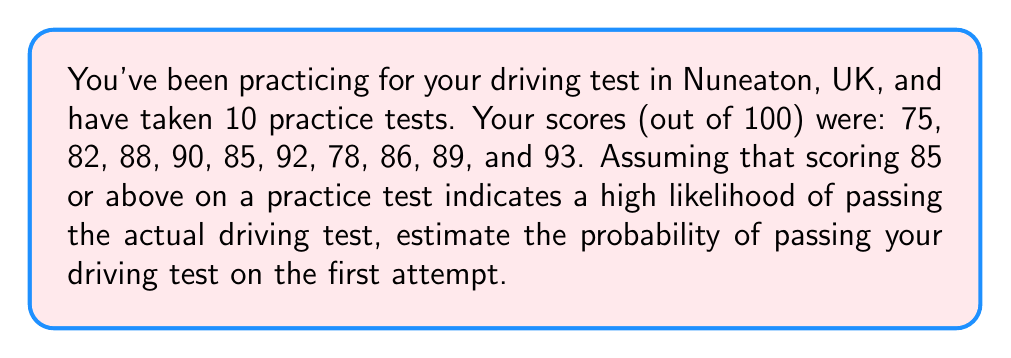Can you solve this math problem? To estimate the probability of passing the driving test on the first attempt, we'll use the given information that scoring 85 or above on a practice test indicates a high likelihood of passing. We'll treat each practice test as an independent event and calculate the proportion of tests where you scored 85 or above.

1. Count the number of practice tests with scores of 85 or above:
   85, 90, 85, 92, 86, 89, 93
   There are 7 scores that meet this criterion.

2. Calculate the probability using the formula:

   $$P(\text{passing}) = \frac{\text{Number of favorable outcomes}}{\text{Total number of outcomes}}$$

   $$P(\text{passing}) = \frac{7}{10} = 0.7$$

3. Convert the decimal to a percentage:

   $$0.7 \times 100\% = 70\%$$

This means that based on your practice test performance, you have an estimated 70% chance of passing your driving test on the first attempt in Nuneaton, UK.

It's important to note that this is a simplified estimation. Actual driving test results may vary due to factors such as test-day conditions, examiner variability, and the specific skills tested during the exam.
Answer: The estimated probability of passing the driving test on the first attempt is 70%. 